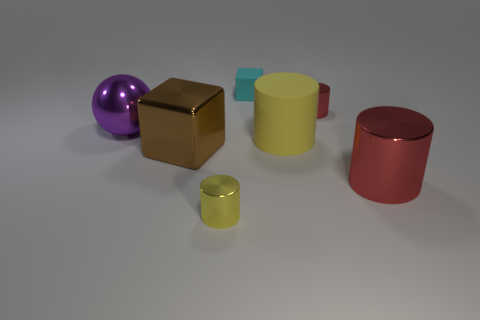Subtract all large red metal cylinders. How many cylinders are left? 3 Add 2 small cyan metal things. How many objects exist? 9 Subtract all red cylinders. How many cylinders are left? 2 Subtract all balls. How many objects are left? 6 Subtract all purple cubes. How many red cylinders are left? 2 Subtract 1 cylinders. How many cylinders are left? 3 Subtract all blue cylinders. Subtract all green balls. How many cylinders are left? 4 Subtract all yellow matte cylinders. Subtract all small purple shiny things. How many objects are left? 6 Add 5 large yellow rubber cylinders. How many large yellow rubber cylinders are left? 6 Add 5 small red shiny things. How many small red shiny things exist? 6 